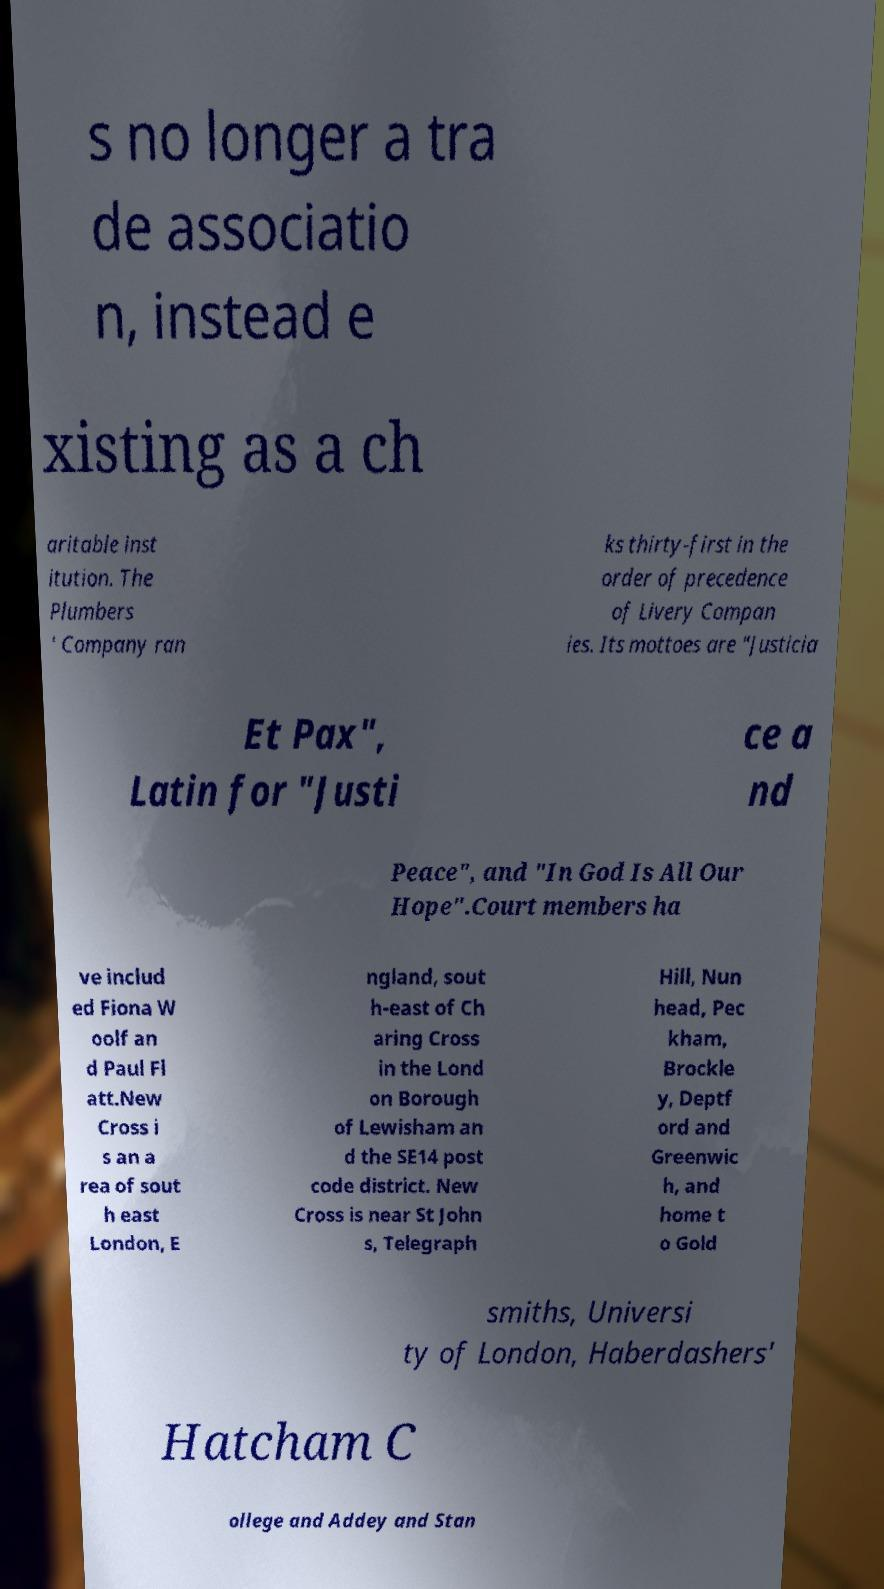Please identify and transcribe the text found in this image. s no longer a tra de associatio n, instead e xisting as a ch aritable inst itution. The Plumbers ' Company ran ks thirty-first in the order of precedence of Livery Compan ies. Its mottoes are "Justicia Et Pax", Latin for "Justi ce a nd Peace", and "In God Is All Our Hope".Court members ha ve includ ed Fiona W oolf an d Paul Fl att.New Cross i s an a rea of sout h east London, E ngland, sout h-east of Ch aring Cross in the Lond on Borough of Lewisham an d the SE14 post code district. New Cross is near St John s, Telegraph Hill, Nun head, Pec kham, Brockle y, Deptf ord and Greenwic h, and home t o Gold smiths, Universi ty of London, Haberdashers' Hatcham C ollege and Addey and Stan 